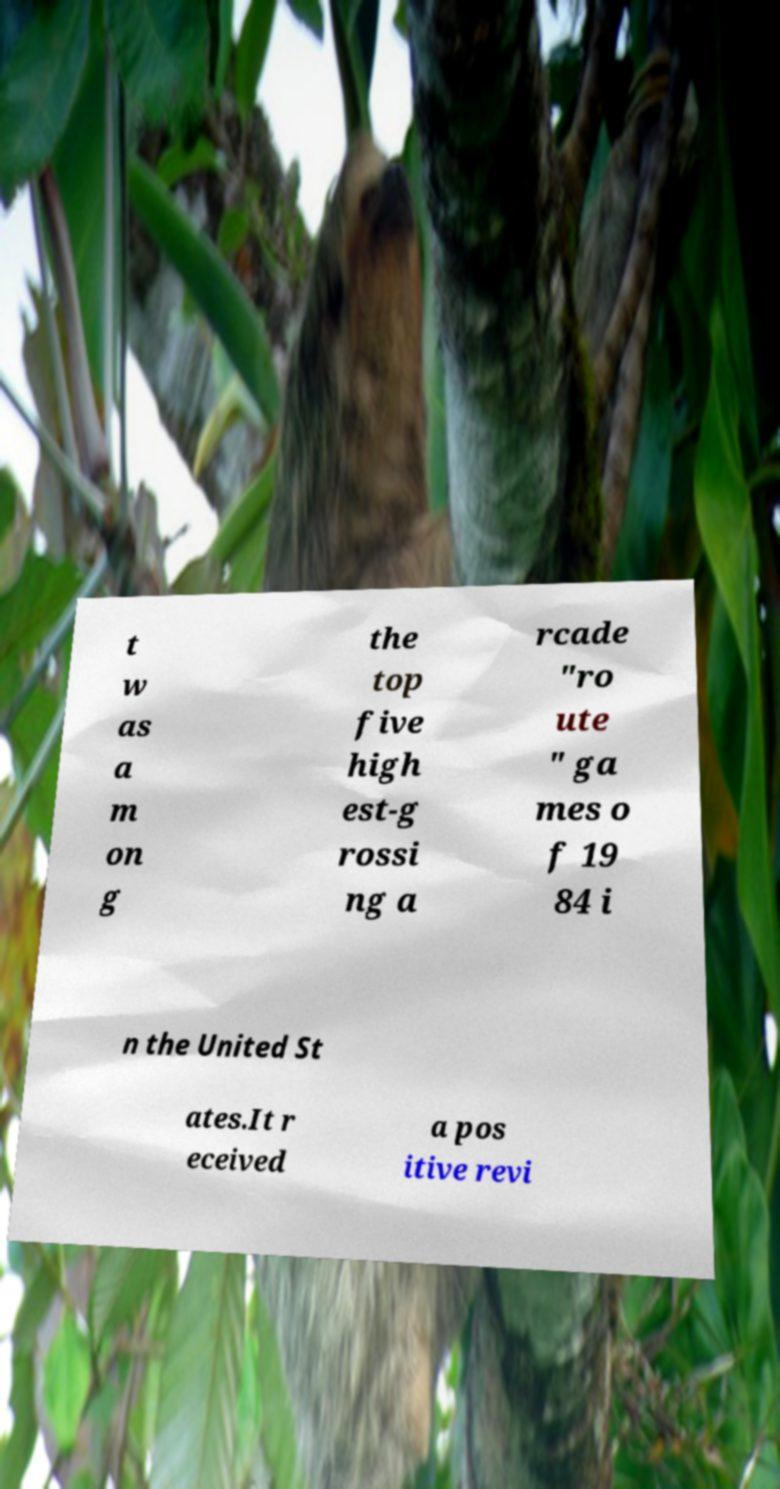There's text embedded in this image that I need extracted. Can you transcribe it verbatim? t w as a m on g the top five high est-g rossi ng a rcade "ro ute " ga mes o f 19 84 i n the United St ates.It r eceived a pos itive revi 